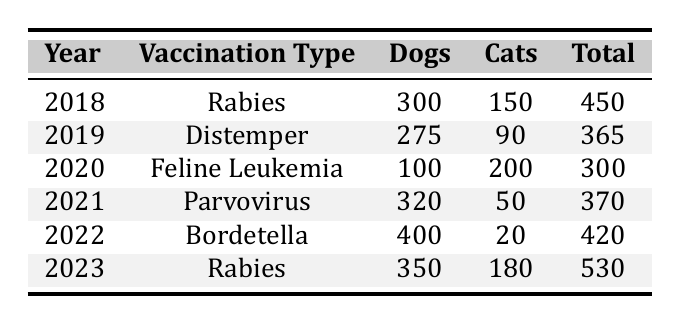What was the total number of dogs vaccinated in 2022? In the table, we can find the row for the year 2022, which shows that 400 dogs were vaccinated.
Answer: 400 How many total vaccinations were recorded in the year 2021? The table shows that the total vaccinations in the year 2021 is listed as 370.
Answer: 370 Which year had the highest number of cat vaccinations? Looking at the table, we see that 200 cats were vaccinated in 2020, which is the highest number compared to other years.
Answer: 2020 What was the difference in the total number of vaccinations between 2019 and 2023? Total vaccinations in 2019 were 365 and in 2023 were 530. The difference is 530 - 365 = 165.
Answer: 165 Did more dogs get vaccinated in 2021 than in 2022? In 2021, 320 dogs were vaccinated, while in 2022, 400 were vaccinated. Since 320 is less than 400, the answer is no.
Answer: No What is the average number of dogs vaccinated over the years 2018 to 2022? The number of dogs vaccinated for the years 2018 to 2022 are: 300, 275, 100, 320, and 400. Adding these gives 1395, and the average over 5 years is 1395 / 5 = 279.
Answer: 279 In which year did the least number of total vaccinations occur? Looking through the total vaccinations for each year, the lowest total is 300 in the year 2020.
Answer: 2020 How many total vaccinations were there from 2018 to 2021 combined? The total vaccinations for those years are 450 (2018) + 365 (2019) + 300 (2020) + 370 (2021) = 1485.
Answer: 1485 Was the total number of vaccinations in 2023 greater than the total of 2021? The total for 2023 is 530, while for 2021 it is 370. Since 530 is greater than 370, the answer is yes.
Answer: Yes What percentage of total vaccinations in 2023 were dogs? In 2023, there were 350 dogs vaccinated out of a total of 530 vaccinations. The percentage is (350 / 530) * 100 ≈ 66.04%.
Answer: 66.04% 